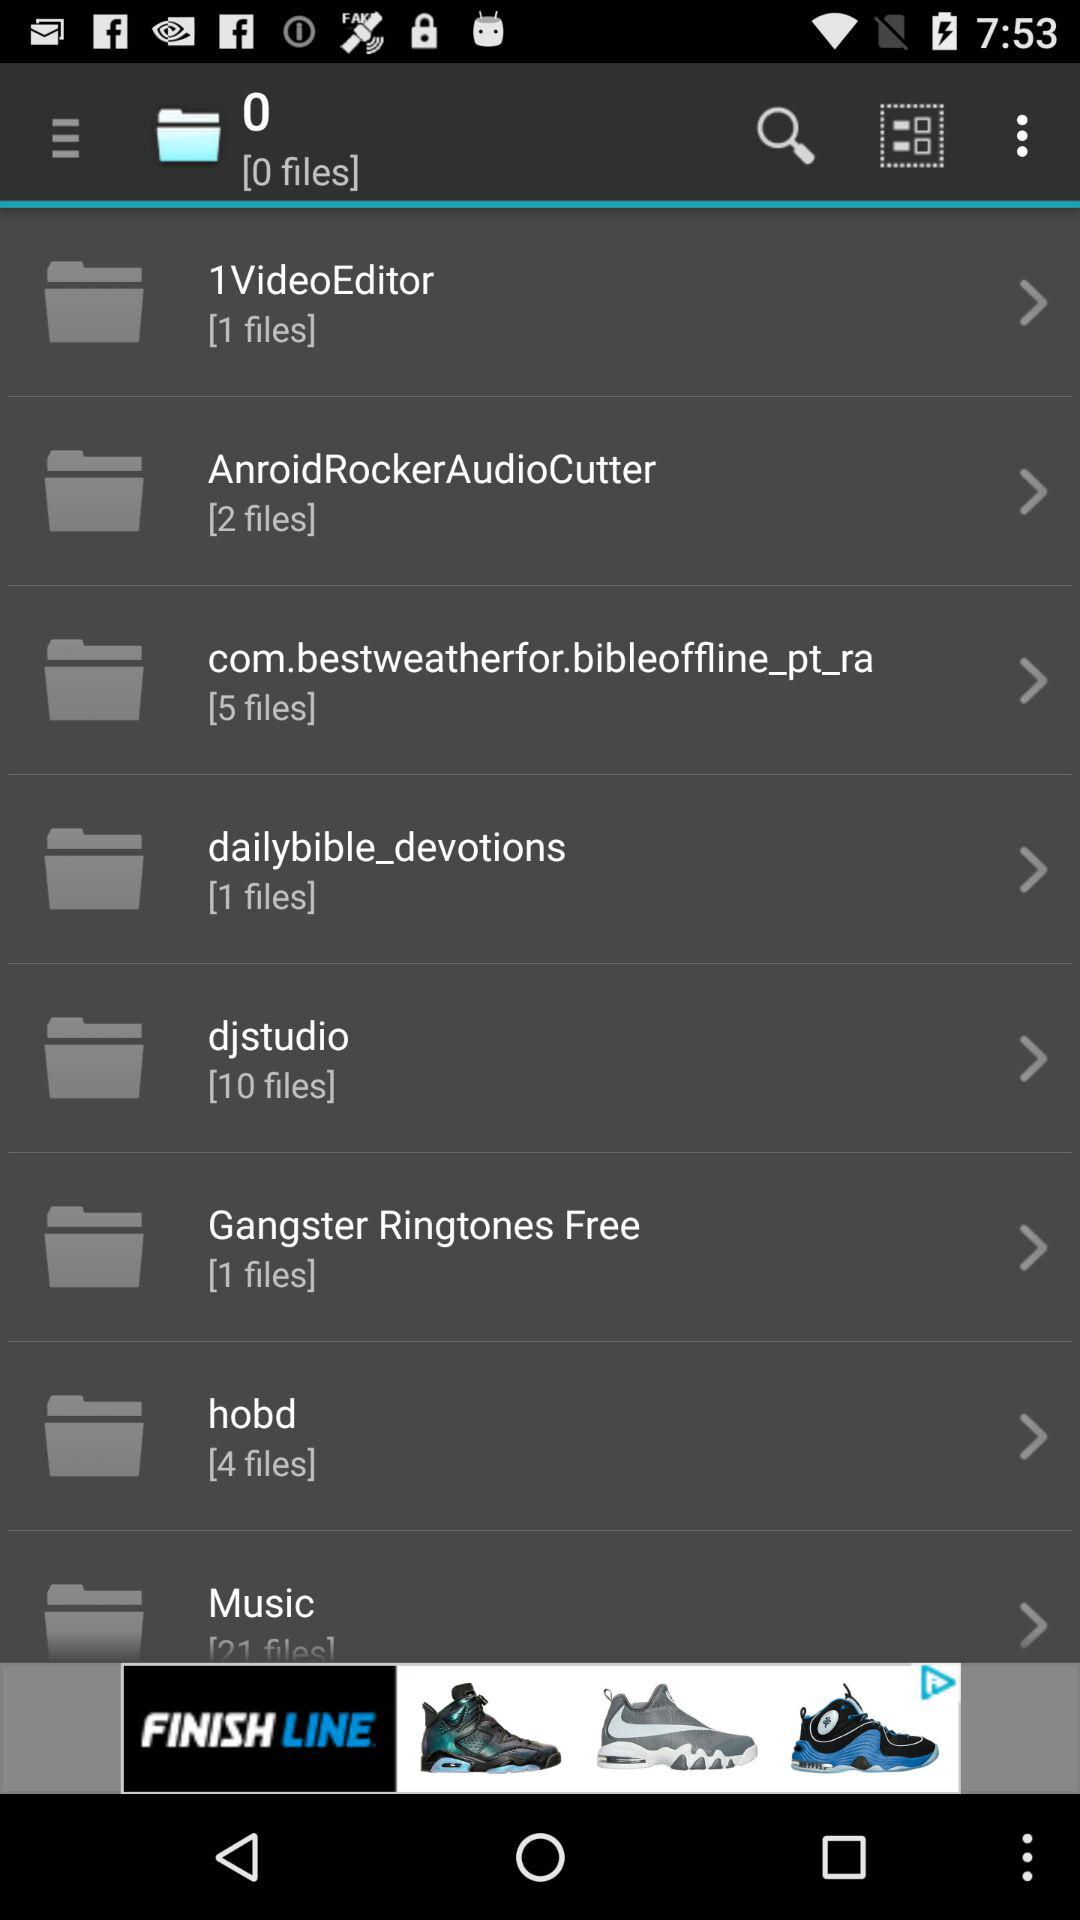How many files are in the Music folder?
Answer the question using a single word or phrase. 21 